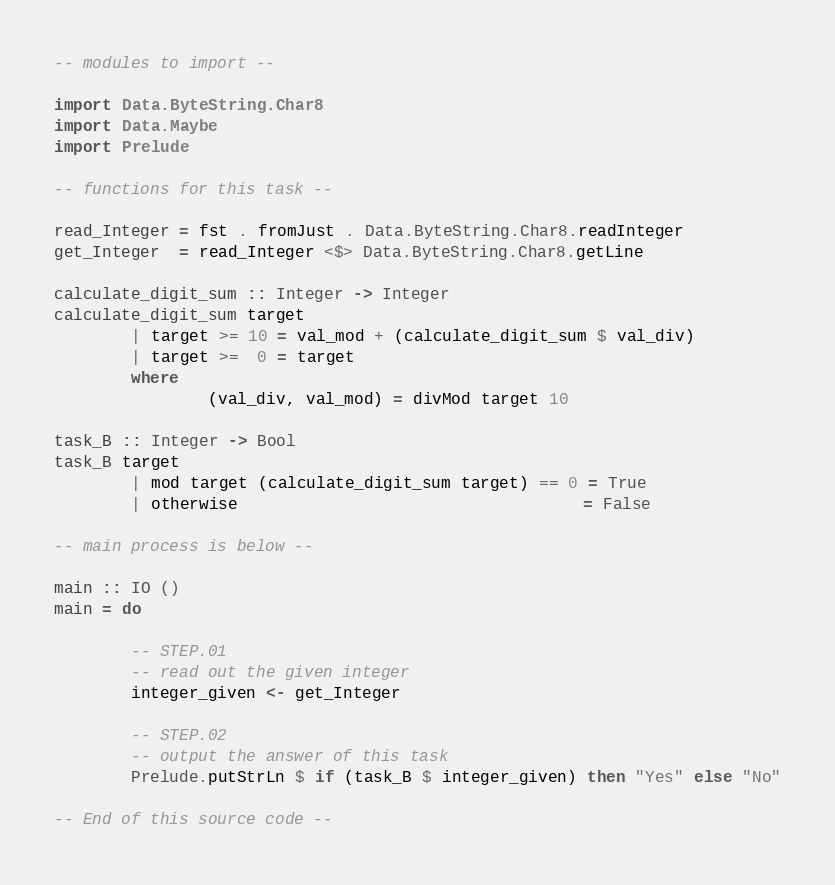<code> <loc_0><loc_0><loc_500><loc_500><_Haskell_>-- modules to import --

import Data.ByteString.Char8
import Data.Maybe
import Prelude

-- functions for this task --

read_Integer = fst . fromJust . Data.ByteString.Char8.readInteger
get_Integer  = read_Integer <$> Data.ByteString.Char8.getLine

calculate_digit_sum :: Integer -> Integer
calculate_digit_sum target
        | target >= 10 = val_mod + (calculate_digit_sum $ val_div)
        | target >=  0 = target
        where
                (val_div, val_mod) = divMod target 10

task_B :: Integer -> Bool
task_B target
        | mod target (calculate_digit_sum target) == 0 = True
        | otherwise                                    = False

-- main process is below --

main :: IO ()
main = do

        -- STEP.01
        -- read out the given integer
        integer_given <- get_Integer

        -- STEP.02
        -- output the answer of this task
        Prelude.putStrLn $ if (task_B $ integer_given) then "Yes" else "No"

-- End of this source code --</code> 